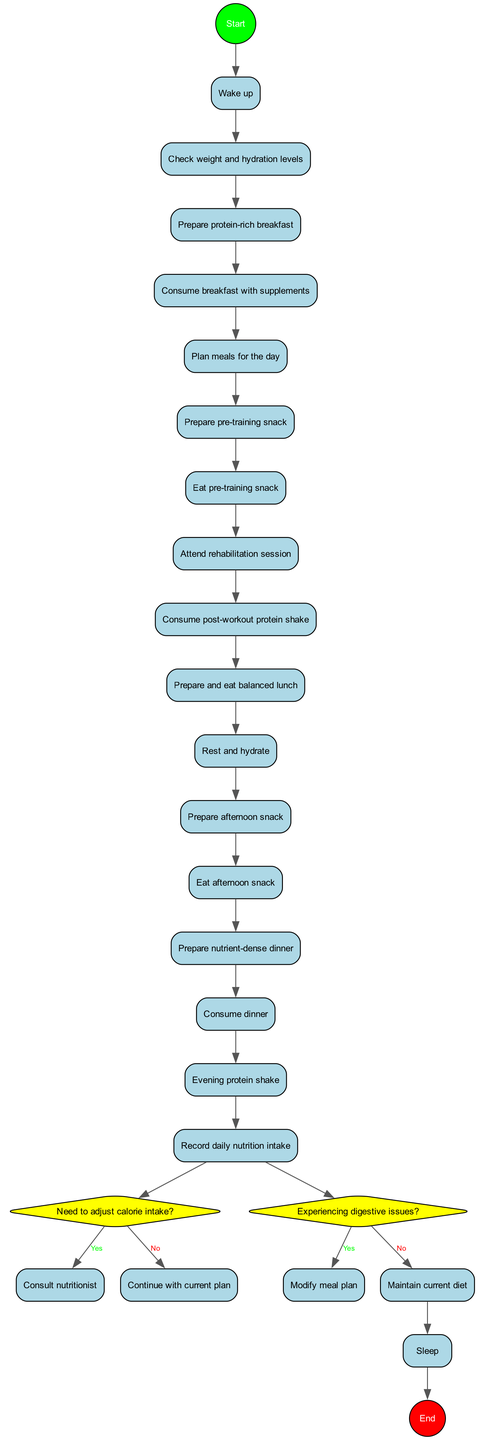What is the starting activity in the diagram? The diagram begins with the "Wake up" activity, which is the first node after the start node.
Answer: Wake up How many total activities are there in the diagram? By counting all listed activities from the starting point to the last one before the decisions, we find there are 15 activities in total.
Answer: 15 What is the last activity before the end node? The last activity before reaching the end node is "Record daily nutrition intake," which is the final activity completed before ending the process.
Answer: Record daily nutrition intake What are the two decisions made in the diagram? The first decision is "Need to adjust calorie intake?" and the second is "Experiencing digestive issues?" These are key branches that determine the flow after completing the activities.
Answer: Need to adjust calorie intake? and Experiencing digestive issues? If "yes" is the answer to the first decision, who do you consult? If the answer to the decision "Need to adjust calorie intake?" is "yes," the next step is to "Consult nutritionist," signifying a proactive measure towards dietary adjustments.
Answer: Consult nutritionist What happens if the answer to the second decision is "no"? If the answer to "Experiencing digestive issues?" is "no," the routine continues with "Maintain current diet," indicating no changes are necessary in the meal plan.
Answer: Maintain current diet Which activity follows "Eat pre-training snack"? After "Eat pre-training snack," the next activity is "Attend rehabilitation session," aligning the nutritional intake directly with the physical activity for recovery.
Answer: Attend rehabilitation session What is the overall direction of the flow in this activity diagram? The flow direction of the diagram goes from the start node to the activities listed, proceeds through decisions, and finally leads to the end node, creating a linear progression with branching decisions.
Answer: Top to bottom with branches 